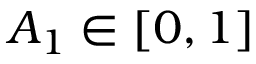Convert formula to latex. <formula><loc_0><loc_0><loc_500><loc_500>A _ { 1 } \in [ 0 , 1 ]</formula> 